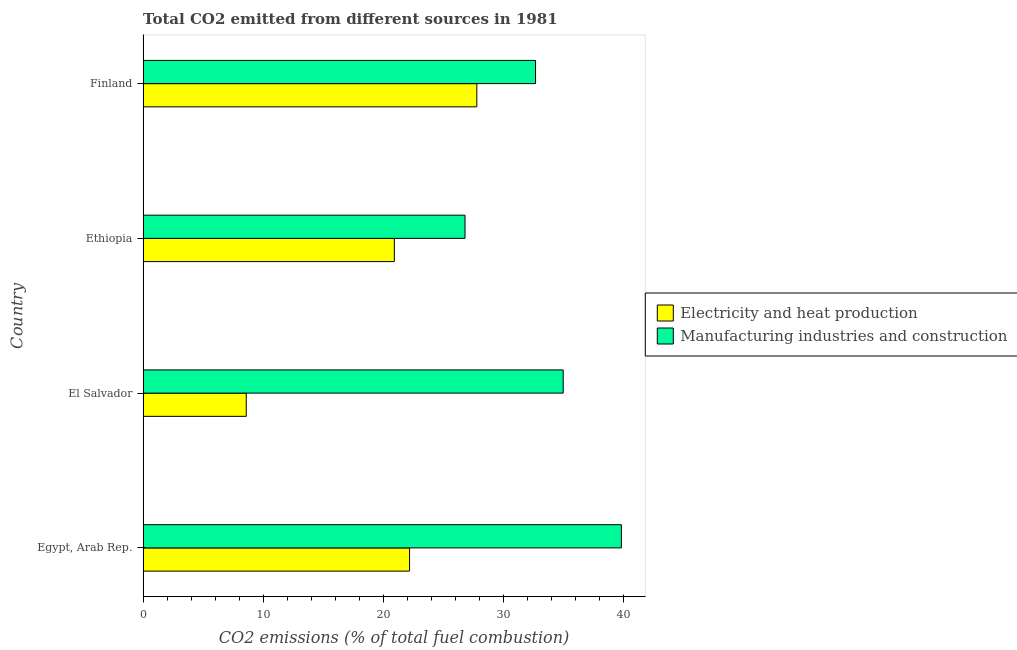How many different coloured bars are there?
Your response must be concise. 2. Are the number of bars per tick equal to the number of legend labels?
Give a very brief answer. Yes. Are the number of bars on each tick of the Y-axis equal?
Offer a very short reply. Yes. How many bars are there on the 3rd tick from the top?
Offer a terse response. 2. In how many cases, is the number of bars for a given country not equal to the number of legend labels?
Keep it short and to the point. 0. What is the co2 emissions due to manufacturing industries in Ethiopia?
Provide a short and direct response. 26.8. Across all countries, what is the maximum co2 emissions due to manufacturing industries?
Give a very brief answer. 39.81. Across all countries, what is the minimum co2 emissions due to electricity and heat production?
Provide a short and direct response. 8.59. In which country was the co2 emissions due to manufacturing industries maximum?
Your response must be concise. Egypt, Arab Rep. In which country was the co2 emissions due to electricity and heat production minimum?
Keep it short and to the point. El Salvador. What is the total co2 emissions due to manufacturing industries in the graph?
Keep it short and to the point. 134.25. What is the difference between the co2 emissions due to manufacturing industries in Egypt, Arab Rep. and that in Finland?
Provide a short and direct response. 7.14. What is the difference between the co2 emissions due to manufacturing industries in Egypt, Arab Rep. and the co2 emissions due to electricity and heat production in El Salvador?
Provide a succinct answer. 31.22. What is the average co2 emissions due to electricity and heat production per country?
Give a very brief answer. 19.87. What is the difference between the co2 emissions due to manufacturing industries and co2 emissions due to electricity and heat production in Ethiopia?
Ensure brevity in your answer.  5.88. In how many countries, is the co2 emissions due to manufacturing industries greater than 24 %?
Give a very brief answer. 4. What is the ratio of the co2 emissions due to electricity and heat production in Egypt, Arab Rep. to that in El Salvador?
Your answer should be compact. 2.58. What is the difference between the highest and the second highest co2 emissions due to electricity and heat production?
Provide a short and direct response. 5.6. What is the difference between the highest and the lowest co2 emissions due to electricity and heat production?
Provide a short and direct response. 19.19. Is the sum of the co2 emissions due to electricity and heat production in Egypt, Arab Rep. and Ethiopia greater than the maximum co2 emissions due to manufacturing industries across all countries?
Your response must be concise. Yes. What does the 1st bar from the top in El Salvador represents?
Provide a succinct answer. Manufacturing industries and construction. What does the 2nd bar from the bottom in Finland represents?
Keep it short and to the point. Manufacturing industries and construction. How many countries are there in the graph?
Keep it short and to the point. 4. What is the difference between two consecutive major ticks on the X-axis?
Provide a succinct answer. 10. Are the values on the major ticks of X-axis written in scientific E-notation?
Your response must be concise. No. Does the graph contain any zero values?
Offer a very short reply. No. What is the title of the graph?
Ensure brevity in your answer.  Total CO2 emitted from different sources in 1981. What is the label or title of the X-axis?
Your answer should be compact. CO2 emissions (% of total fuel combustion). What is the CO2 emissions (% of total fuel combustion) in Electricity and heat production in Egypt, Arab Rep.?
Provide a short and direct response. 22.18. What is the CO2 emissions (% of total fuel combustion) of Manufacturing industries and construction in Egypt, Arab Rep.?
Offer a very short reply. 39.81. What is the CO2 emissions (% of total fuel combustion) in Electricity and heat production in El Salvador?
Offer a terse response. 8.59. What is the CO2 emissions (% of total fuel combustion) of Manufacturing industries and construction in El Salvador?
Your answer should be very brief. 34.97. What is the CO2 emissions (% of total fuel combustion) of Electricity and heat production in Ethiopia?
Your response must be concise. 20.92. What is the CO2 emissions (% of total fuel combustion) of Manufacturing industries and construction in Ethiopia?
Ensure brevity in your answer.  26.8. What is the CO2 emissions (% of total fuel combustion) of Electricity and heat production in Finland?
Offer a very short reply. 27.78. What is the CO2 emissions (% of total fuel combustion) of Manufacturing industries and construction in Finland?
Your answer should be very brief. 32.67. Across all countries, what is the maximum CO2 emissions (% of total fuel combustion) in Electricity and heat production?
Your response must be concise. 27.78. Across all countries, what is the maximum CO2 emissions (% of total fuel combustion) in Manufacturing industries and construction?
Your answer should be very brief. 39.81. Across all countries, what is the minimum CO2 emissions (% of total fuel combustion) of Electricity and heat production?
Offer a very short reply. 8.59. Across all countries, what is the minimum CO2 emissions (% of total fuel combustion) in Manufacturing industries and construction?
Keep it short and to the point. 26.8. What is the total CO2 emissions (% of total fuel combustion) in Electricity and heat production in the graph?
Your response must be concise. 79.47. What is the total CO2 emissions (% of total fuel combustion) in Manufacturing industries and construction in the graph?
Your response must be concise. 134.25. What is the difference between the CO2 emissions (% of total fuel combustion) in Electricity and heat production in Egypt, Arab Rep. and that in El Salvador?
Provide a succinct answer. 13.59. What is the difference between the CO2 emissions (% of total fuel combustion) of Manufacturing industries and construction in Egypt, Arab Rep. and that in El Salvador?
Keep it short and to the point. 4.84. What is the difference between the CO2 emissions (% of total fuel combustion) in Electricity and heat production in Egypt, Arab Rep. and that in Ethiopia?
Your answer should be very brief. 1.27. What is the difference between the CO2 emissions (% of total fuel combustion) of Manufacturing industries and construction in Egypt, Arab Rep. and that in Ethiopia?
Provide a succinct answer. 13.01. What is the difference between the CO2 emissions (% of total fuel combustion) in Electricity and heat production in Egypt, Arab Rep. and that in Finland?
Keep it short and to the point. -5.6. What is the difference between the CO2 emissions (% of total fuel combustion) in Manufacturing industries and construction in Egypt, Arab Rep. and that in Finland?
Offer a terse response. 7.14. What is the difference between the CO2 emissions (% of total fuel combustion) in Electricity and heat production in El Salvador and that in Ethiopia?
Your response must be concise. -12.33. What is the difference between the CO2 emissions (% of total fuel combustion) of Manufacturing industries and construction in El Salvador and that in Ethiopia?
Provide a short and direct response. 8.17. What is the difference between the CO2 emissions (% of total fuel combustion) of Electricity and heat production in El Salvador and that in Finland?
Your response must be concise. -19.19. What is the difference between the CO2 emissions (% of total fuel combustion) in Manufacturing industries and construction in El Salvador and that in Finland?
Your response must be concise. 2.3. What is the difference between the CO2 emissions (% of total fuel combustion) of Electricity and heat production in Ethiopia and that in Finland?
Ensure brevity in your answer.  -6.87. What is the difference between the CO2 emissions (% of total fuel combustion) of Manufacturing industries and construction in Ethiopia and that in Finland?
Your response must be concise. -5.87. What is the difference between the CO2 emissions (% of total fuel combustion) in Electricity and heat production in Egypt, Arab Rep. and the CO2 emissions (% of total fuel combustion) in Manufacturing industries and construction in El Salvador?
Your answer should be very brief. -12.79. What is the difference between the CO2 emissions (% of total fuel combustion) of Electricity and heat production in Egypt, Arab Rep. and the CO2 emissions (% of total fuel combustion) of Manufacturing industries and construction in Ethiopia?
Make the answer very short. -4.62. What is the difference between the CO2 emissions (% of total fuel combustion) of Electricity and heat production in Egypt, Arab Rep. and the CO2 emissions (% of total fuel combustion) of Manufacturing industries and construction in Finland?
Your answer should be compact. -10.49. What is the difference between the CO2 emissions (% of total fuel combustion) of Electricity and heat production in El Salvador and the CO2 emissions (% of total fuel combustion) of Manufacturing industries and construction in Ethiopia?
Keep it short and to the point. -18.21. What is the difference between the CO2 emissions (% of total fuel combustion) of Electricity and heat production in El Salvador and the CO2 emissions (% of total fuel combustion) of Manufacturing industries and construction in Finland?
Your response must be concise. -24.08. What is the difference between the CO2 emissions (% of total fuel combustion) of Electricity and heat production in Ethiopia and the CO2 emissions (% of total fuel combustion) of Manufacturing industries and construction in Finland?
Your answer should be compact. -11.75. What is the average CO2 emissions (% of total fuel combustion) in Electricity and heat production per country?
Keep it short and to the point. 19.87. What is the average CO2 emissions (% of total fuel combustion) in Manufacturing industries and construction per country?
Provide a short and direct response. 33.56. What is the difference between the CO2 emissions (% of total fuel combustion) of Electricity and heat production and CO2 emissions (% of total fuel combustion) of Manufacturing industries and construction in Egypt, Arab Rep.?
Offer a very short reply. -17.63. What is the difference between the CO2 emissions (% of total fuel combustion) in Electricity and heat production and CO2 emissions (% of total fuel combustion) in Manufacturing industries and construction in El Salvador?
Provide a short and direct response. -26.38. What is the difference between the CO2 emissions (% of total fuel combustion) in Electricity and heat production and CO2 emissions (% of total fuel combustion) in Manufacturing industries and construction in Ethiopia?
Offer a very short reply. -5.88. What is the difference between the CO2 emissions (% of total fuel combustion) of Electricity and heat production and CO2 emissions (% of total fuel combustion) of Manufacturing industries and construction in Finland?
Your answer should be very brief. -4.89. What is the ratio of the CO2 emissions (% of total fuel combustion) of Electricity and heat production in Egypt, Arab Rep. to that in El Salvador?
Give a very brief answer. 2.58. What is the ratio of the CO2 emissions (% of total fuel combustion) in Manufacturing industries and construction in Egypt, Arab Rep. to that in El Salvador?
Your answer should be compact. 1.14. What is the ratio of the CO2 emissions (% of total fuel combustion) in Electricity and heat production in Egypt, Arab Rep. to that in Ethiopia?
Your answer should be compact. 1.06. What is the ratio of the CO2 emissions (% of total fuel combustion) in Manufacturing industries and construction in Egypt, Arab Rep. to that in Ethiopia?
Your response must be concise. 1.49. What is the ratio of the CO2 emissions (% of total fuel combustion) of Electricity and heat production in Egypt, Arab Rep. to that in Finland?
Your response must be concise. 0.8. What is the ratio of the CO2 emissions (% of total fuel combustion) in Manufacturing industries and construction in Egypt, Arab Rep. to that in Finland?
Give a very brief answer. 1.22. What is the ratio of the CO2 emissions (% of total fuel combustion) in Electricity and heat production in El Salvador to that in Ethiopia?
Provide a succinct answer. 0.41. What is the ratio of the CO2 emissions (% of total fuel combustion) of Manufacturing industries and construction in El Salvador to that in Ethiopia?
Provide a short and direct response. 1.3. What is the ratio of the CO2 emissions (% of total fuel combustion) of Electricity and heat production in El Salvador to that in Finland?
Keep it short and to the point. 0.31. What is the ratio of the CO2 emissions (% of total fuel combustion) of Manufacturing industries and construction in El Salvador to that in Finland?
Make the answer very short. 1.07. What is the ratio of the CO2 emissions (% of total fuel combustion) of Electricity and heat production in Ethiopia to that in Finland?
Give a very brief answer. 0.75. What is the ratio of the CO2 emissions (% of total fuel combustion) in Manufacturing industries and construction in Ethiopia to that in Finland?
Your answer should be very brief. 0.82. What is the difference between the highest and the second highest CO2 emissions (% of total fuel combustion) in Electricity and heat production?
Keep it short and to the point. 5.6. What is the difference between the highest and the second highest CO2 emissions (% of total fuel combustion) in Manufacturing industries and construction?
Offer a very short reply. 4.84. What is the difference between the highest and the lowest CO2 emissions (% of total fuel combustion) in Electricity and heat production?
Provide a succinct answer. 19.19. What is the difference between the highest and the lowest CO2 emissions (% of total fuel combustion) of Manufacturing industries and construction?
Provide a succinct answer. 13.01. 